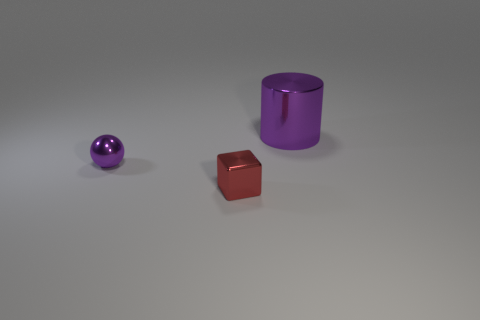What number of things are either objects that are behind the metallic ball or purple shiny objects that are in front of the purple shiny cylinder?
Your answer should be very brief. 2. What material is the tiny sphere that is the same color as the metallic cylinder?
Make the answer very short. Metal. What number of matte objects are tiny brown balls or small red blocks?
Provide a short and direct response. 0. What is the shape of the large metal thing?
Your answer should be very brief. Cylinder. How many green cylinders have the same material as the small purple ball?
Your answer should be very brief. 0. There is a block that is made of the same material as the purple cylinder; what is its color?
Offer a very short reply. Red. There is a purple thing that is on the left side of the shiny cylinder; is it the same size as the cylinder?
Keep it short and to the point. No. What shape is the tiny object that is to the right of the purple object that is to the left of the small thing in front of the tiny purple shiny object?
Ensure brevity in your answer.  Cube. The small thing that is on the right side of the purple object that is in front of the large metal object is what shape?
Your response must be concise. Cube. Are any big yellow matte blocks visible?
Provide a succinct answer. No. 